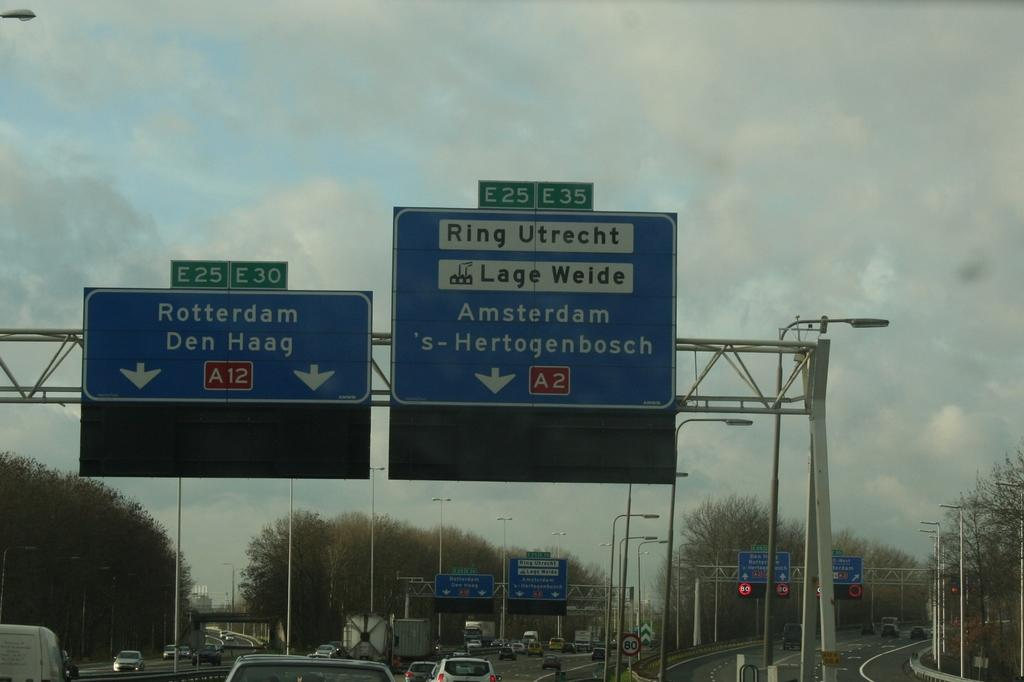<image>
Describe the image concisely. Two overhead signs on a highway, one showing exits for Rotterdam and Den Haag. 